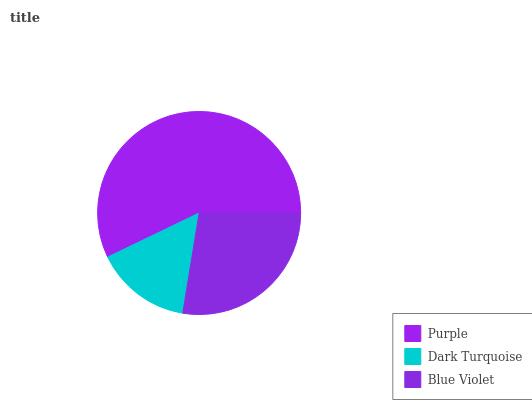Is Dark Turquoise the minimum?
Answer yes or no. Yes. Is Purple the maximum?
Answer yes or no. Yes. Is Blue Violet the minimum?
Answer yes or no. No. Is Blue Violet the maximum?
Answer yes or no. No. Is Blue Violet greater than Dark Turquoise?
Answer yes or no. Yes. Is Dark Turquoise less than Blue Violet?
Answer yes or no. Yes. Is Dark Turquoise greater than Blue Violet?
Answer yes or no. No. Is Blue Violet less than Dark Turquoise?
Answer yes or no. No. Is Blue Violet the high median?
Answer yes or no. Yes. Is Blue Violet the low median?
Answer yes or no. Yes. Is Dark Turquoise the high median?
Answer yes or no. No. Is Purple the low median?
Answer yes or no. No. 